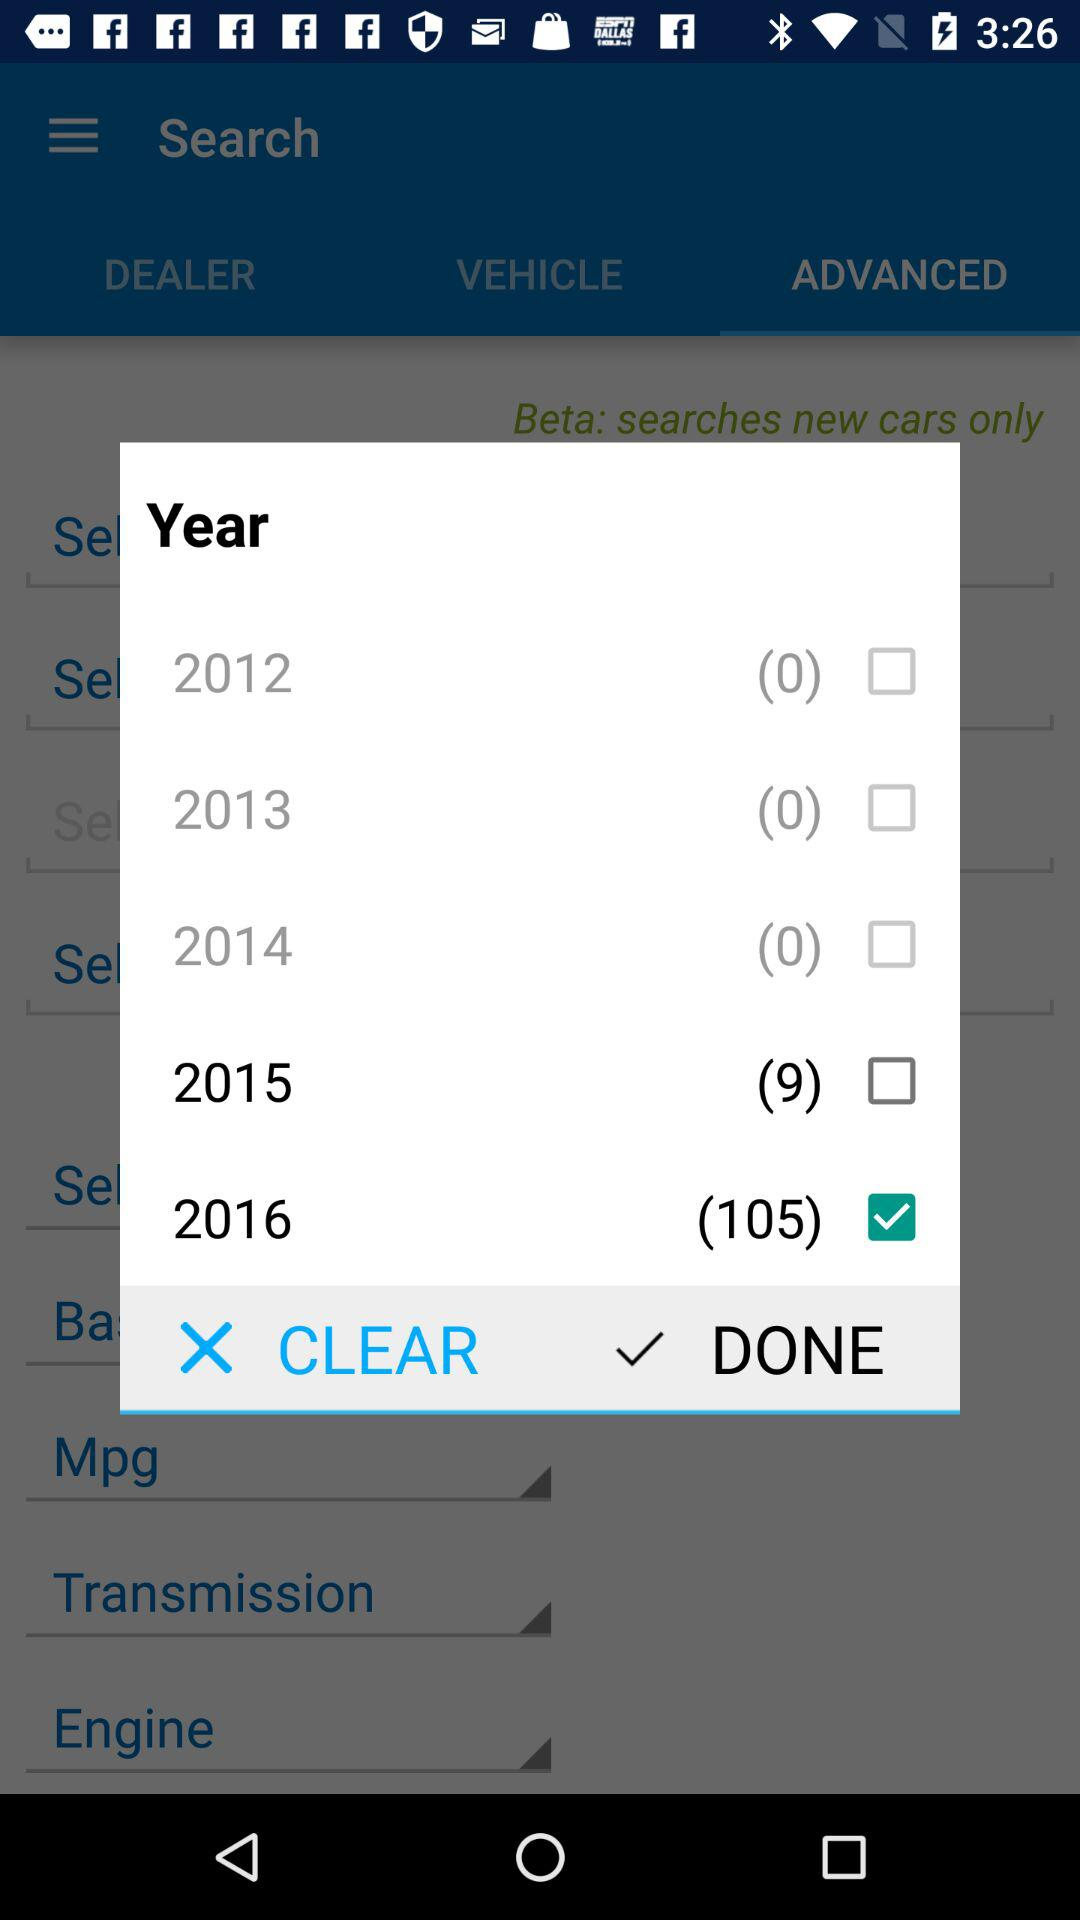What is the checked year? The checked year is 2016. 